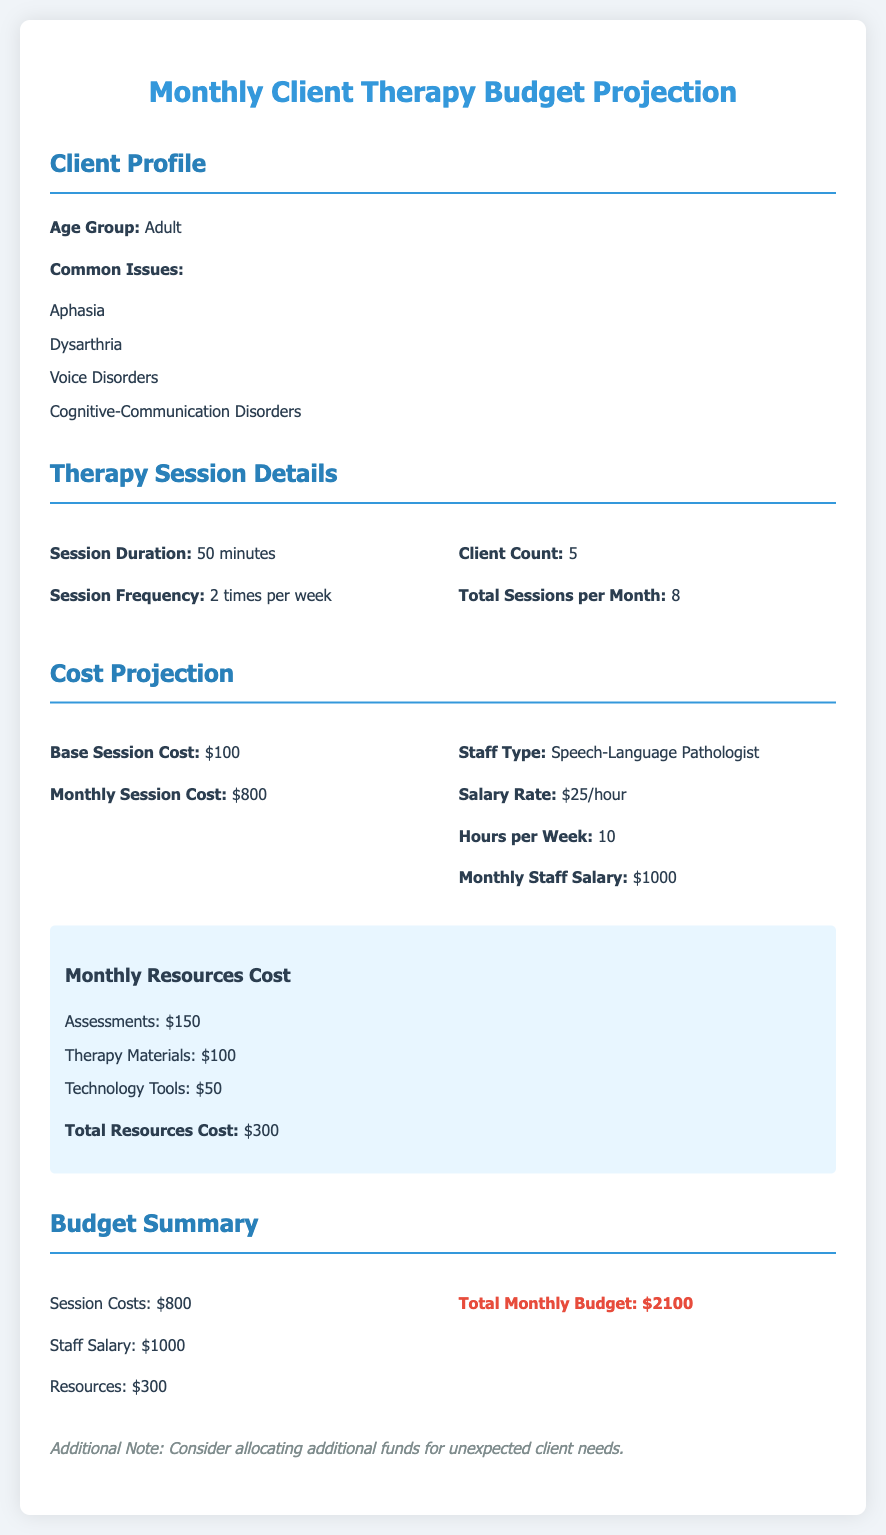What is the age group of clients? The document specifies that the age group of clients is Adult.
Answer: Adult How many clients are there? The document states the client count is 5.
Answer: 5 What is the base session cost? The base session cost mentioned in the document is $100.
Answer: $100 How often are the therapy sessions scheduled per week? According to the document, the therapy session frequency is 2 times per week.
Answer: 2 times per week What is the total resources cost? The document summarizes the total resources cost as $300.
Answer: $300 How much is the staff salary per month? The document outlines the monthly staff salary as $1000.
Answer: $1000 What is the total monthly budget projected? The total monthly budget, as per the document, is $2100.
Answer: $2100 What issues are commonly addressed in adult clients? The document lists several common issues including Aphasia, Dysarthria, Voice Disorders, and Cognitive-Communication Disorders.
Answer: Aphasia, Dysarthria, Voice Disorders, Cognitive-Communication Disorders What is the duration of each therapy session? The document indicates the session duration is 50 minutes.
Answer: 50 minutes 